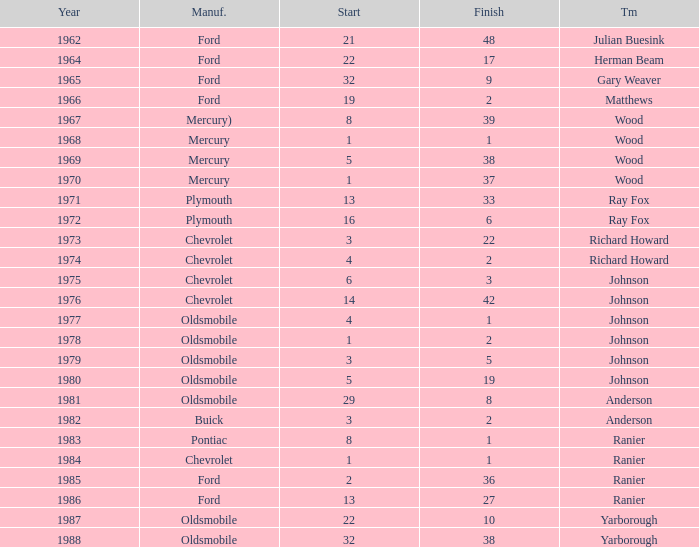For a race with a start below 3, made by buick, and conducted after 1978, what is the quickest finishing time? None. 